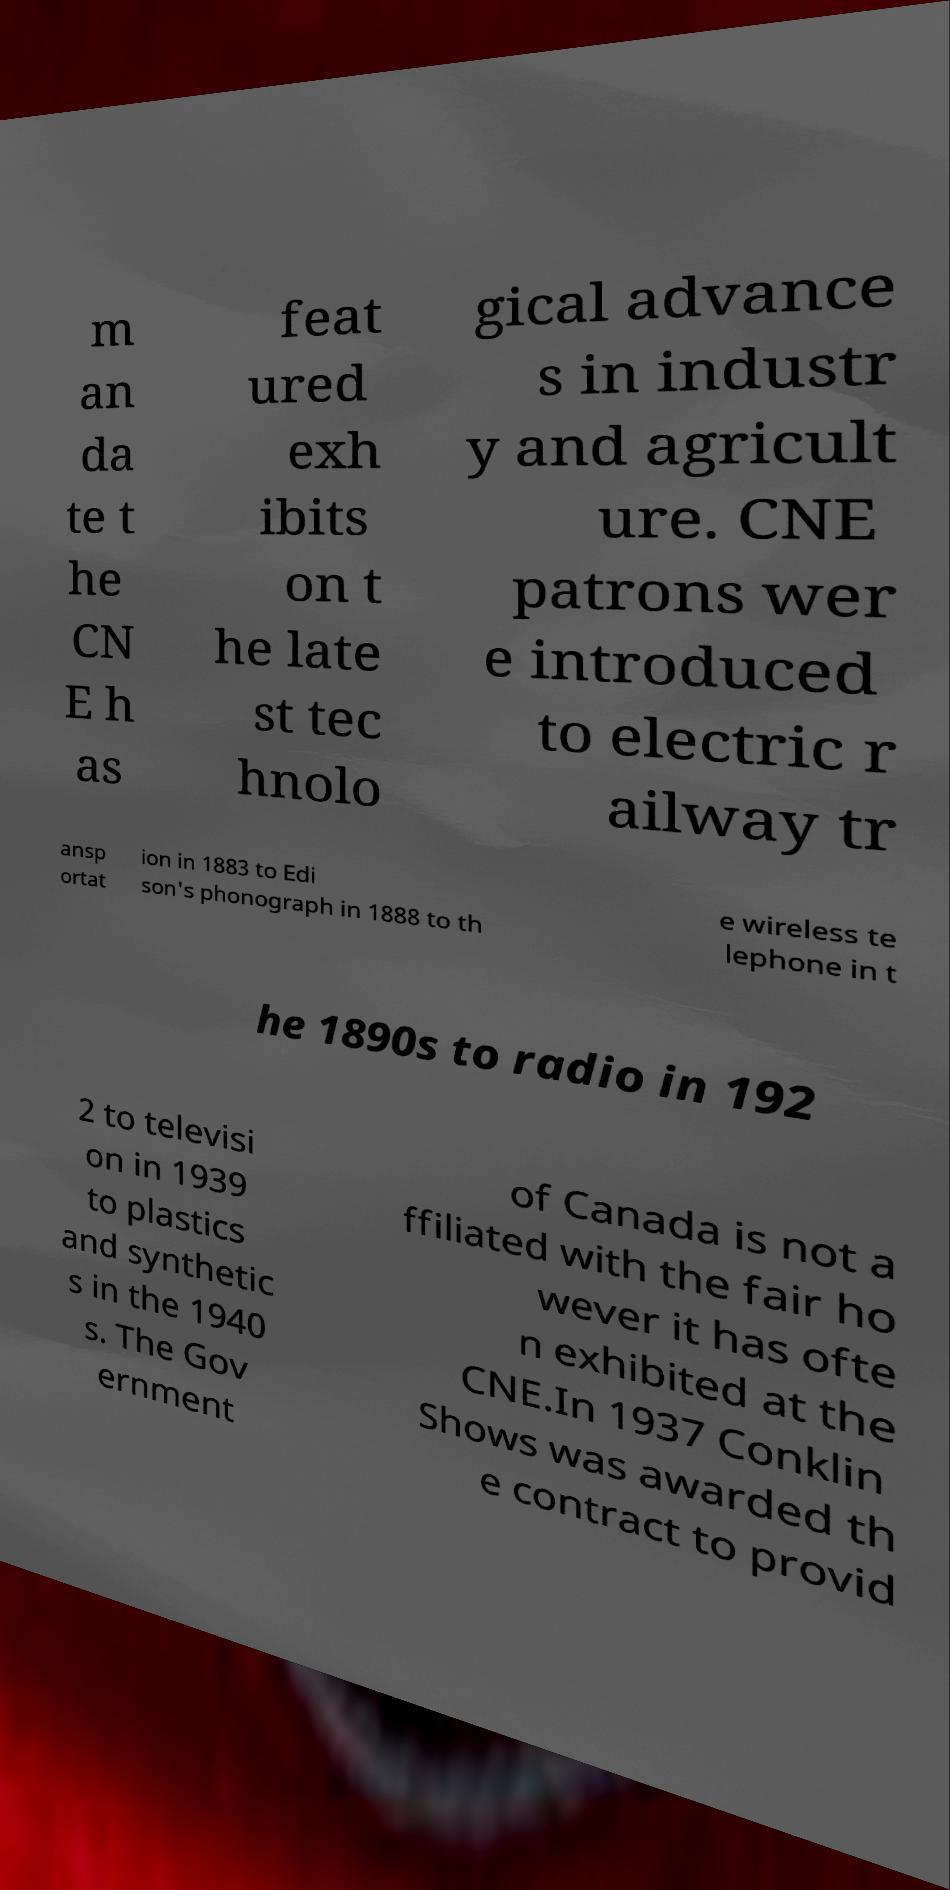What messages or text are displayed in this image? I need them in a readable, typed format. m an da te t he CN E h as feat ured exh ibits on t he late st tec hnolo gical advance s in industr y and agricult ure. CNE patrons wer e introduced to electric r ailway tr ansp ortat ion in 1883 to Edi son's phonograph in 1888 to th e wireless te lephone in t he 1890s to radio in 192 2 to televisi on in 1939 to plastics and synthetic s in the 1940 s. The Gov ernment of Canada is not a ffiliated with the fair ho wever it has ofte n exhibited at the CNE.In 1937 Conklin Shows was awarded th e contract to provid 